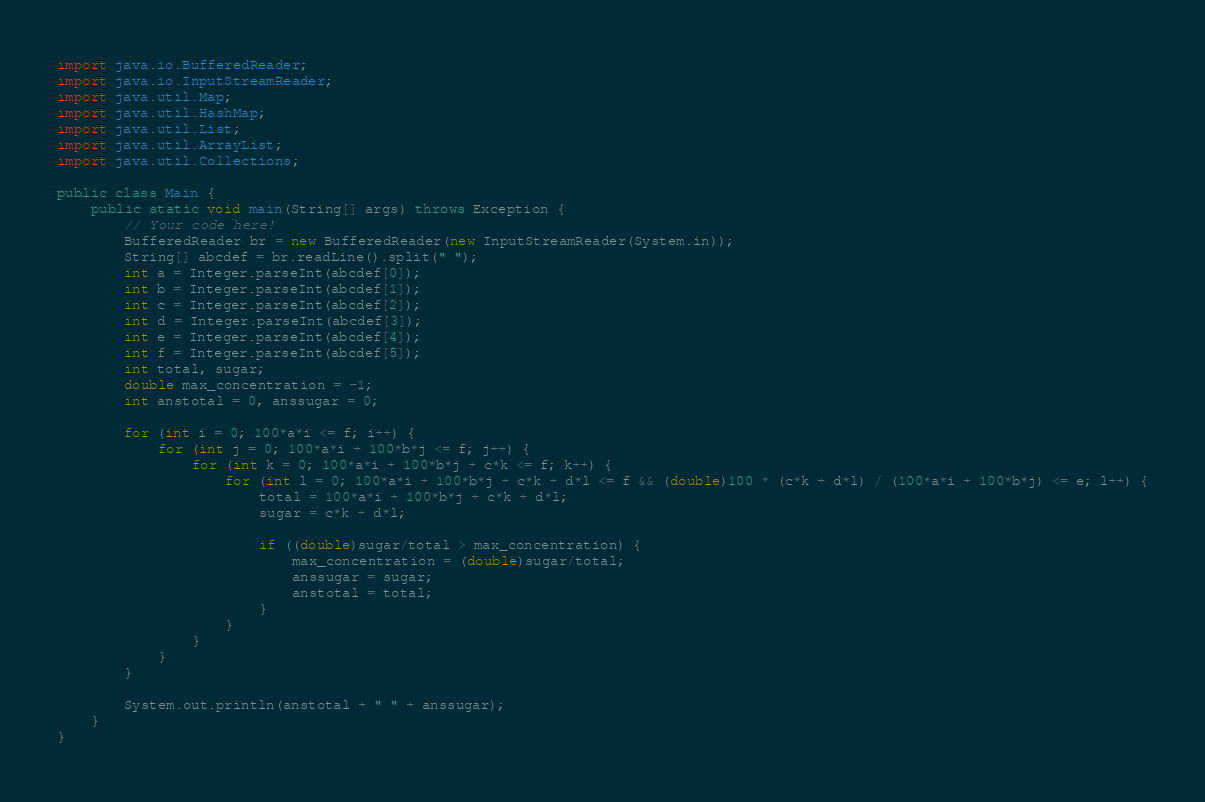Convert code to text. <code><loc_0><loc_0><loc_500><loc_500><_Java_>import java.io.BufferedReader;
import java.io.InputStreamReader;
import java.util.Map;
import java.util.HashMap;
import java.util.List;
import java.util.ArrayList;
import java.util.Collections;

public class Main {
    public static void main(String[] args) throws Exception {
        // Your code here!
        BufferedReader br = new BufferedReader(new InputStreamReader(System.in));
        String[] abcdef = br.readLine().split(" ");
        int a = Integer.parseInt(abcdef[0]);
        int b = Integer.parseInt(abcdef[1]);
        int c = Integer.parseInt(abcdef[2]);
        int d = Integer.parseInt(abcdef[3]);
        int e = Integer.parseInt(abcdef[4]);
        int f = Integer.parseInt(abcdef[5]);
        int total, sugar;
        double max_concentration = -1;
        int anstotal = 0, anssugar = 0;
        
        for (int i = 0; 100*a*i <= f; i++) {
            for (int j = 0; 100*a*i + 100*b*j <= f; j++) {
                for (int k = 0; 100*a*i + 100*b*j + c*k <= f; k++) {
                    for (int l = 0; 100*a*i + 100*b*j + c*k + d*l <= f && (double)100 * (c*k + d*l) / (100*a*i + 100*b*j) <= e; l++) {
                        total = 100*a*i + 100*b*j + c*k + d*l;
                        sugar = c*k + d*l;
                        
                        if ((double)sugar/total > max_concentration) {
                            max_concentration = (double)sugar/total;
                            anssugar = sugar;
                            anstotal = total;
                        }
                    }
                }
            }
        }
        
        System.out.println(anstotal + " " + anssugar);
    }
}
</code> 